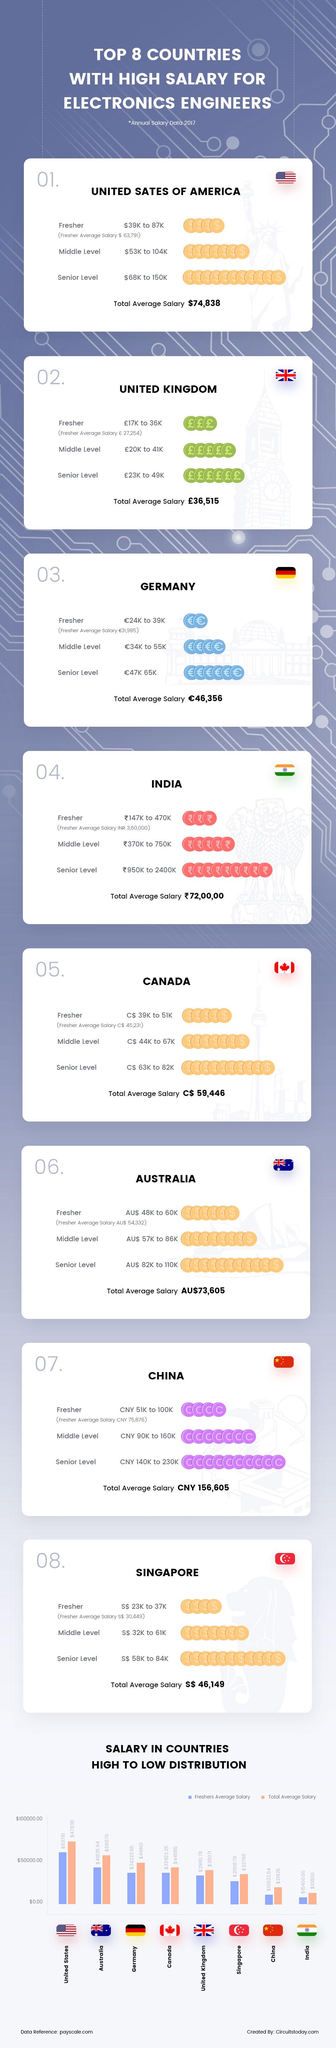Mention a couple of crucial points in this snapshot. According to a recent survey, the average salary for fresh electronic engineering graduates in China in 2017 was approximately CNY 75,876. According to data from 2017, the average total salary for electronics engineers in India was approximately ₹ 72,00,000. According to a report by the top eight countries in 2017, the United States of America offered the highest pay scale for electronics engineers. In 2017, the average salary for fresh electronic engineering graduates in the UK was approximately 27,254 pounds. The salary range for senior-level electronics engineers in the UK in 2017 was between 23,000 pounds and 49,000 pounds. 